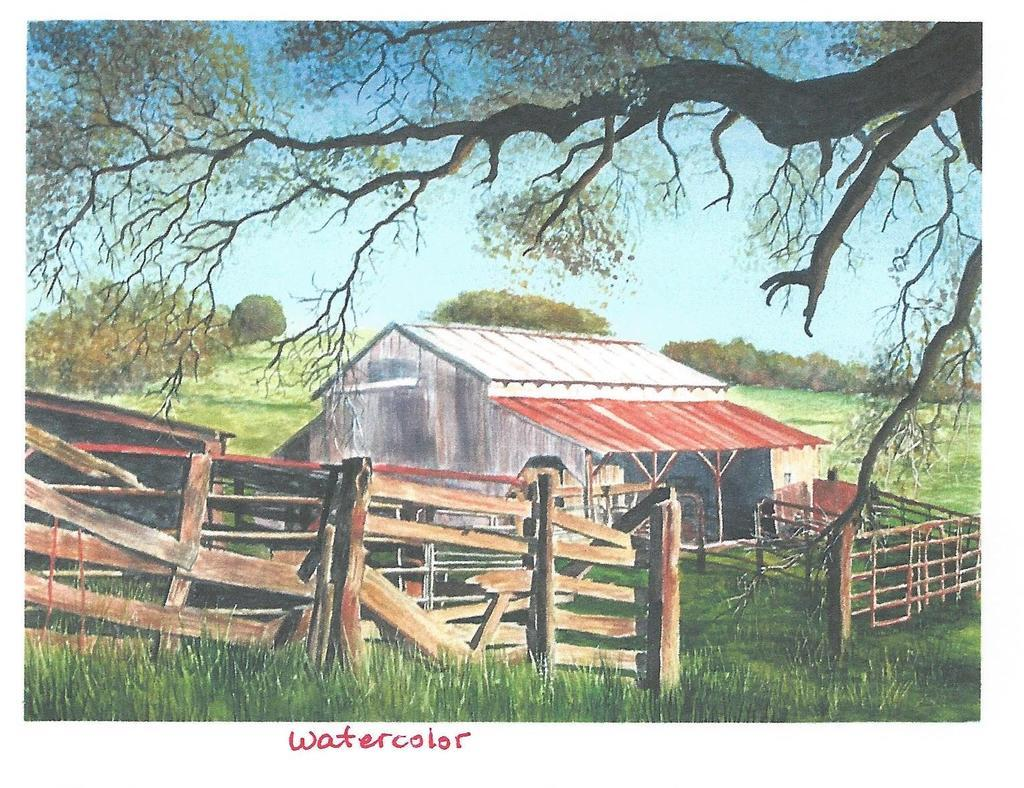<image>
Render a clear and concise summary of the photo. a postcard with words Water color show a rural barn 